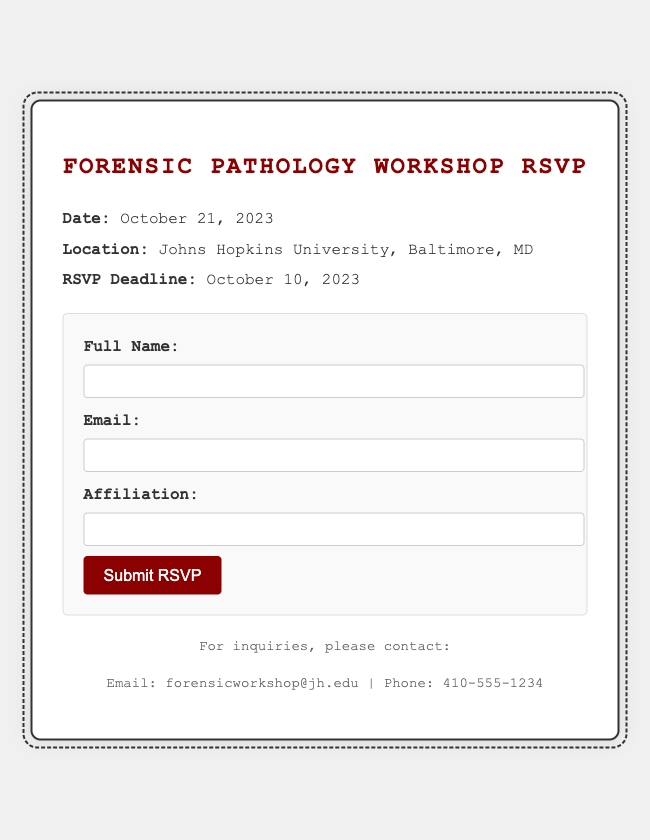what is the date of the workshop? The date of the workshop is explicitly stated in the document, which is October 21, 2023.
Answer: October 21, 2023 where is the workshop taking place? The location of the workshop is mentioned directly in the document as Johns Hopkins University, Baltimore, MD.
Answer: Johns Hopkins University, Baltimore, MD what is the RSVP deadline? The deadline for RSVP is provided in the document as October 10, 2023.
Answer: October 10, 2023 what type of form is included in the document? The document includes a form for participants to RSVP to the workshop, specifically an RSVP form.
Answer: RSVP form how many input fields are present in the RSVP form? The RSVP form contains three input fields: Full Name, Email, and Affiliation.
Answer: Three who is the target audience for this RSVP card? This RSVP card is primarily targeted towards individuals interested in forensic pathology, likely medical professionals and students in the field.
Answer: Forensic pathology professionals and students what action does the RSVP form prompt users to take? The RSVP form encourages users to submit their RSVP by clicking on the “Submit RSVP” button.
Answer: Submit RSVP 